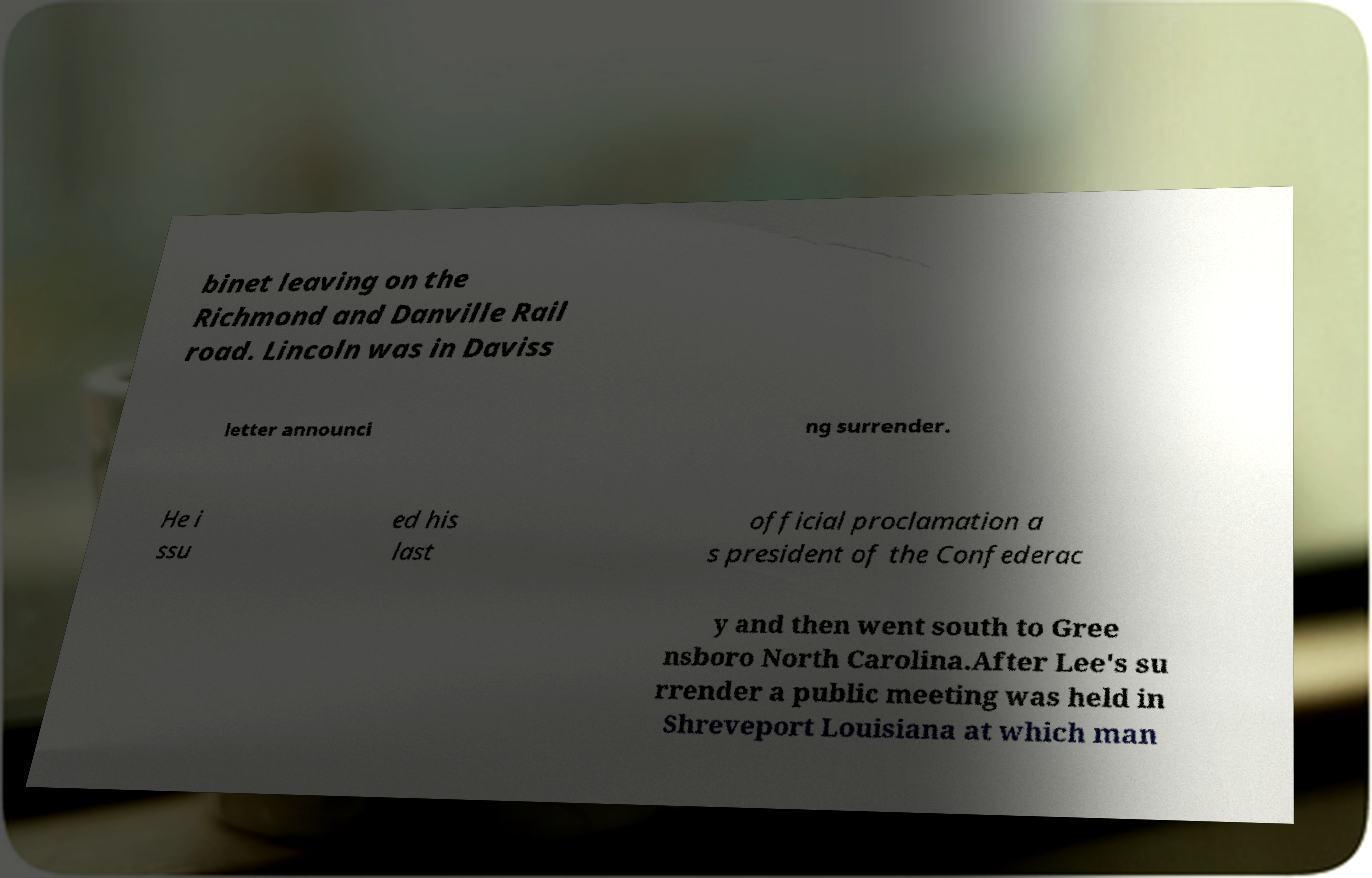I need the written content from this picture converted into text. Can you do that? binet leaving on the Richmond and Danville Rail road. Lincoln was in Daviss letter announci ng surrender. He i ssu ed his last official proclamation a s president of the Confederac y and then went south to Gree nsboro North Carolina.After Lee's su rrender a public meeting was held in Shreveport Louisiana at which man 